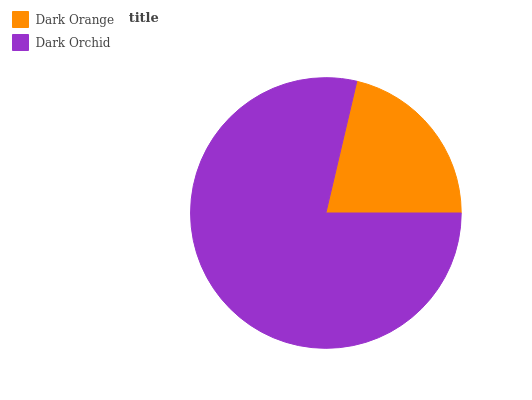Is Dark Orange the minimum?
Answer yes or no. Yes. Is Dark Orchid the maximum?
Answer yes or no. Yes. Is Dark Orchid the minimum?
Answer yes or no. No. Is Dark Orchid greater than Dark Orange?
Answer yes or no. Yes. Is Dark Orange less than Dark Orchid?
Answer yes or no. Yes. Is Dark Orange greater than Dark Orchid?
Answer yes or no. No. Is Dark Orchid less than Dark Orange?
Answer yes or no. No. Is Dark Orchid the high median?
Answer yes or no. Yes. Is Dark Orange the low median?
Answer yes or no. Yes. Is Dark Orange the high median?
Answer yes or no. No. Is Dark Orchid the low median?
Answer yes or no. No. 